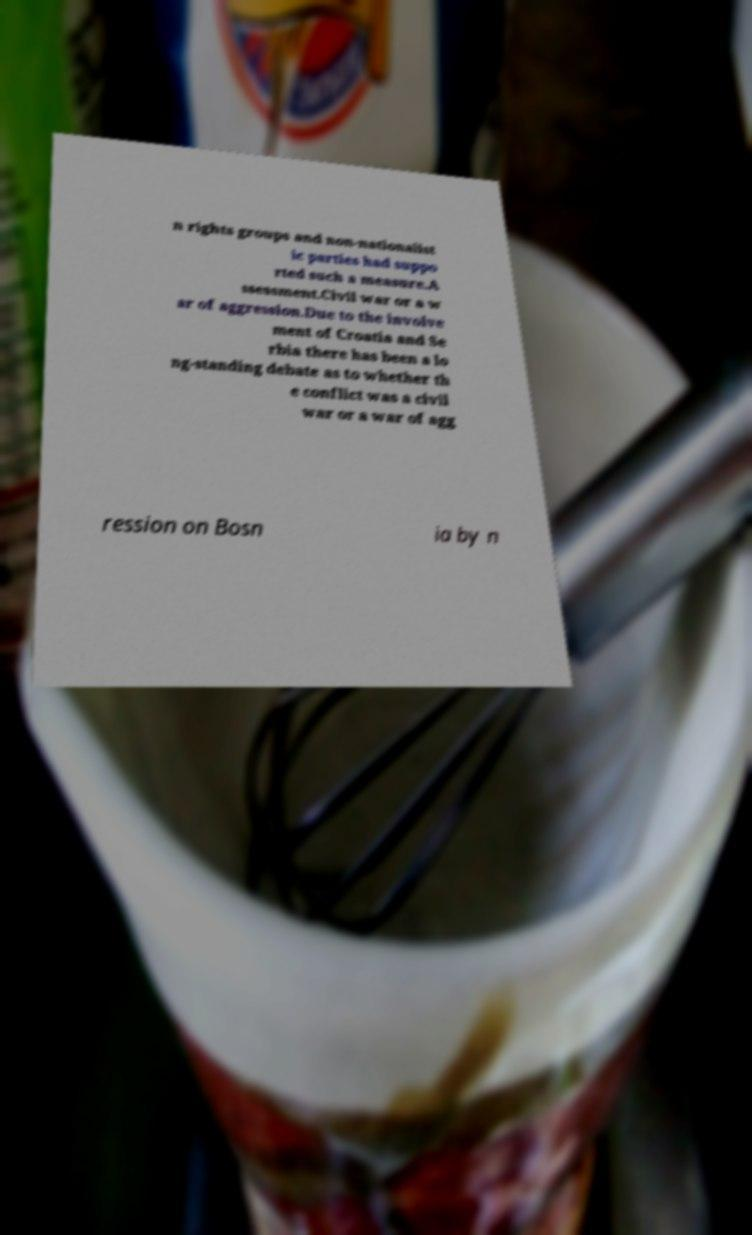Can you accurately transcribe the text from the provided image for me? n rights groups and non-nationalist ic parties had suppo rted such a measure.A ssessment.Civil war or a w ar of aggression.Due to the involve ment of Croatia and Se rbia there has been a lo ng-standing debate as to whether th e conflict was a civil war or a war of agg ression on Bosn ia by n 